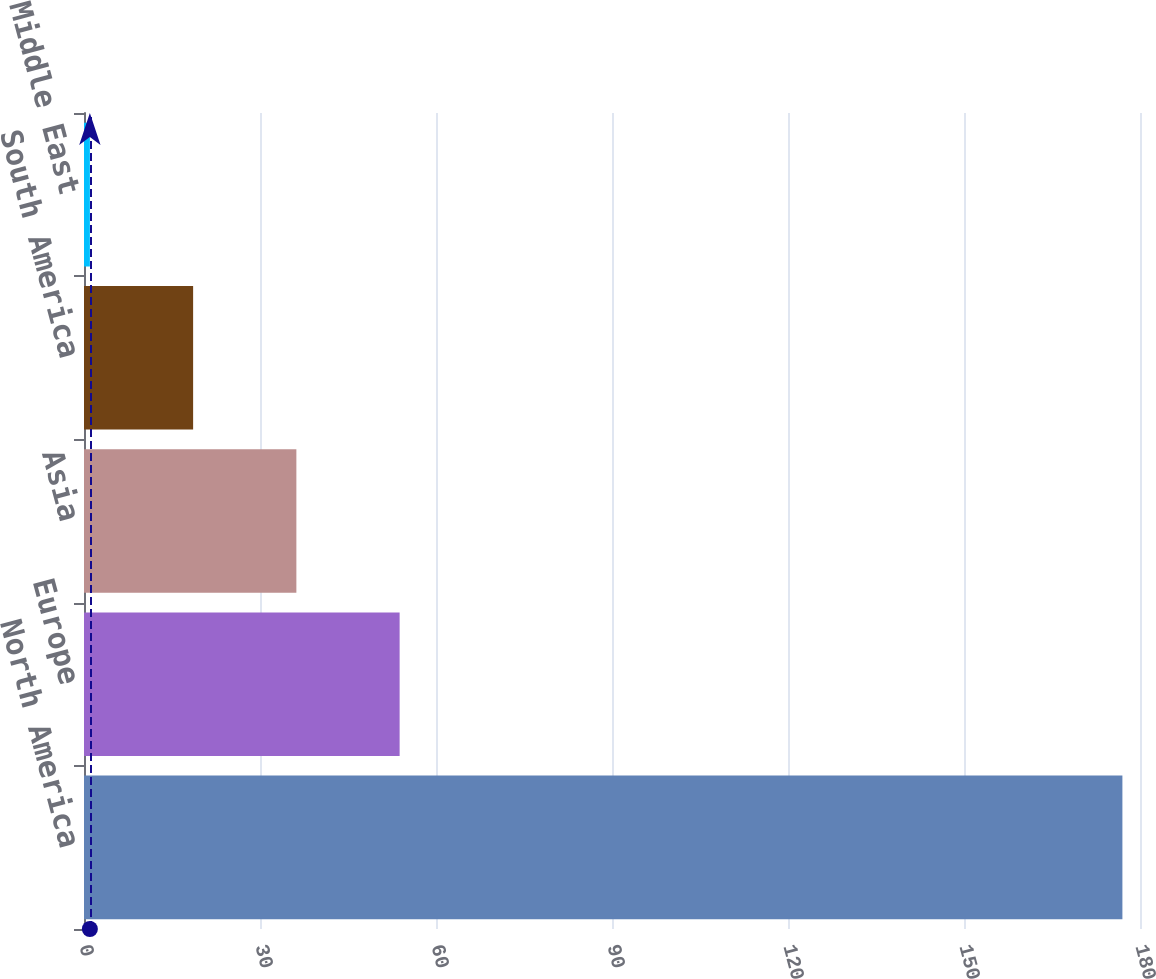<chart> <loc_0><loc_0><loc_500><loc_500><bar_chart><fcel>North America<fcel>Europe<fcel>Asia<fcel>South America<fcel>Middle East<nl><fcel>177<fcel>53.8<fcel>36.2<fcel>18.6<fcel>1<nl></chart> 